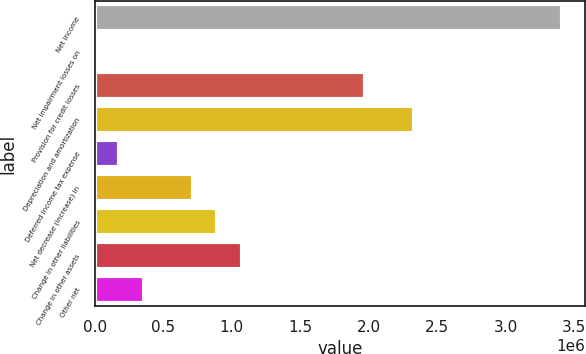Convert chart to OTSL. <chart><loc_0><loc_0><loc_500><loc_500><bar_chart><fcel>Net income<fcel>Net impairment losses on<fcel>Provision for credit losses<fcel>Depreciation and amortization<fcel>Deferred income tax expense<fcel>Net decrease (increase) in<fcel>Change in other liabilities<fcel>Change in other assets<fcel>Other net<nl><fcel>3.40957e+06<fcel>27<fcel>1.97397e+06<fcel>2.33287e+06<fcel>179477<fcel>717826<fcel>897276<fcel>1.07673e+06<fcel>358927<nl></chart> 